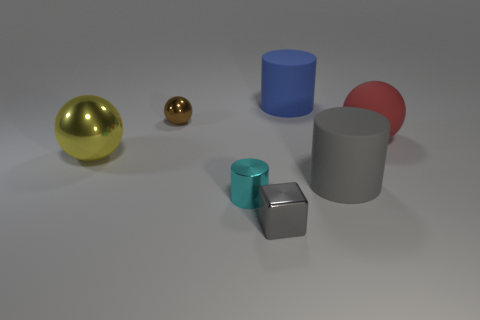The thing that is the same color as the small metallic block is what size?
Make the answer very short. Large. How many brown things are metal cylinders or tiny metal things?
Make the answer very short. 1. Is the number of big yellow metallic objects behind the tiny gray block the same as the number of blue metallic cylinders?
Give a very brief answer. No. How many things are either small purple metallic spheres or rubber objects that are left of the big gray thing?
Provide a short and direct response. 1. Is there a big blue thing made of the same material as the large red object?
Offer a terse response. Yes. There is a big metal thing that is the same shape as the small brown metallic object; what is its color?
Provide a succinct answer. Yellow. Is the material of the yellow thing the same as the gray object that is to the left of the large blue cylinder?
Your answer should be compact. Yes. There is a large object on the left side of the gray object that is on the left side of the gray cylinder; what shape is it?
Offer a very short reply. Sphere. There is a gray thing right of the gray metallic cube; is its size the same as the yellow shiny thing?
Your answer should be very brief. Yes. How many other things are there of the same shape as the large gray rubber thing?
Provide a short and direct response. 2. 